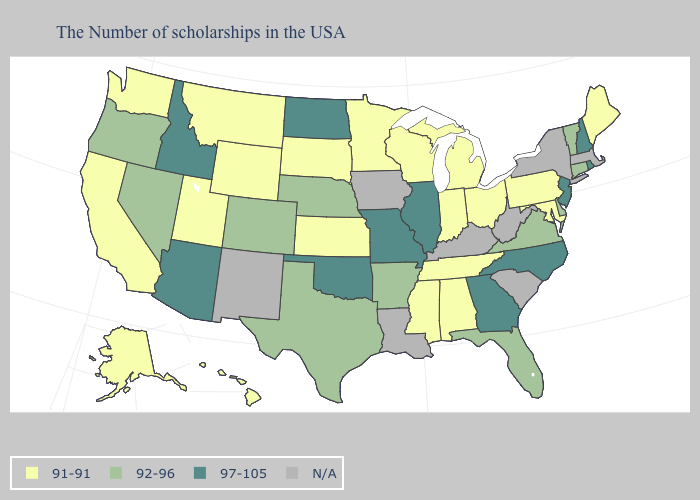What is the lowest value in the USA?
Keep it brief. 91-91. What is the value of Alaska?
Concise answer only. 91-91. What is the highest value in the USA?
Answer briefly. 97-105. Does the map have missing data?
Answer briefly. Yes. Is the legend a continuous bar?
Be succinct. No. Name the states that have a value in the range N/A?
Write a very short answer. Massachusetts, New York, South Carolina, West Virginia, Kentucky, Louisiana, Iowa, New Mexico. Which states have the lowest value in the USA?
Concise answer only. Maine, Maryland, Pennsylvania, Ohio, Michigan, Indiana, Alabama, Tennessee, Wisconsin, Mississippi, Minnesota, Kansas, South Dakota, Wyoming, Utah, Montana, California, Washington, Alaska, Hawaii. What is the highest value in the West ?
Concise answer only. 97-105. Among the states that border Oregon , which have the highest value?
Be succinct. Idaho. Does the map have missing data?
Keep it brief. Yes. What is the highest value in the West ?
Be succinct. 97-105. Does Indiana have the lowest value in the MidWest?
Give a very brief answer. Yes. Name the states that have a value in the range 97-105?
Short answer required. Rhode Island, New Hampshire, New Jersey, North Carolina, Georgia, Illinois, Missouri, Oklahoma, North Dakota, Arizona, Idaho. Name the states that have a value in the range 91-91?
Give a very brief answer. Maine, Maryland, Pennsylvania, Ohio, Michigan, Indiana, Alabama, Tennessee, Wisconsin, Mississippi, Minnesota, Kansas, South Dakota, Wyoming, Utah, Montana, California, Washington, Alaska, Hawaii. Name the states that have a value in the range 97-105?
Answer briefly. Rhode Island, New Hampshire, New Jersey, North Carolina, Georgia, Illinois, Missouri, Oklahoma, North Dakota, Arizona, Idaho. 